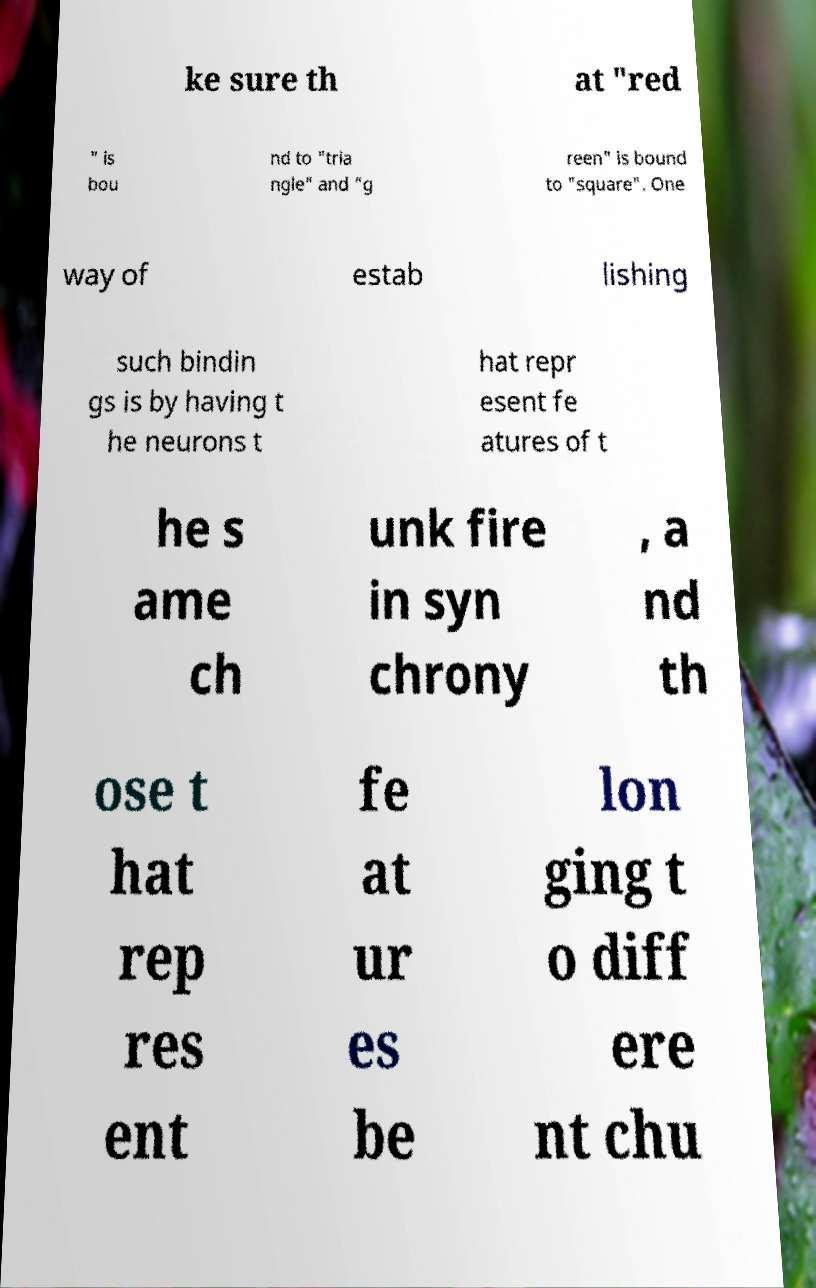Could you assist in decoding the text presented in this image and type it out clearly? ke sure th at "red " is bou nd to "tria ngle" and "g reen" is bound to "square". One way of estab lishing such bindin gs is by having t he neurons t hat repr esent fe atures of t he s ame ch unk fire in syn chrony , a nd th ose t hat rep res ent fe at ur es be lon ging t o diff ere nt chu 